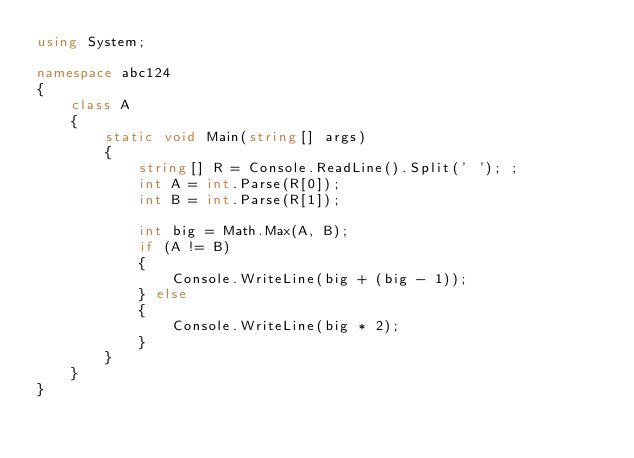<code> <loc_0><loc_0><loc_500><loc_500><_C#_>using System;

namespace abc124
{
    class A
    {
        static void Main(string[] args)
        {
            string[] R = Console.ReadLine().Split(' '); ;
            int A = int.Parse(R[0]);
            int B = int.Parse(R[1]);

            int big = Math.Max(A, B);
            if (A != B)
            {
                Console.WriteLine(big + (big - 1));
            } else
            {
                Console.WriteLine(big * 2);
            }
        }
    }
}
</code> 